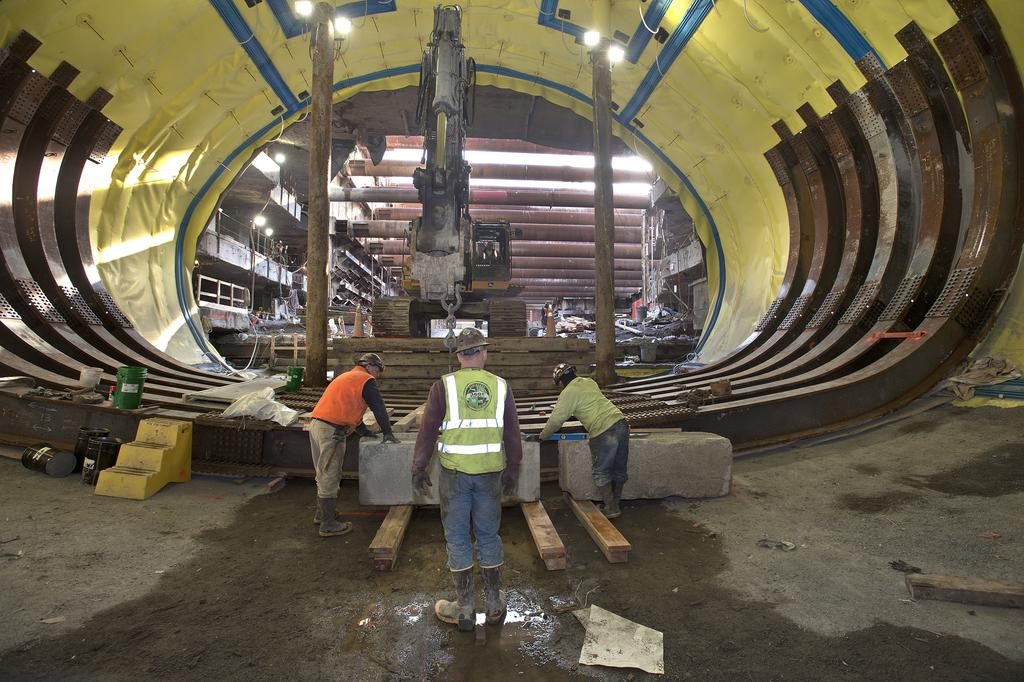How many people are on the floor in the image? There are three people on the floor in the image. What is the main subject of the image? The main subject of the image is a construction of a submarine. What else can be seen in the image besides the people and the submarine? There is a vehicle, pillars, and a building in the image. What type of office supplies can be seen on the people's desks in the image? There are no desks or office supplies present in the image; it features three people on the floor and a construction of a submarine. What color is the scarf worn by the person in the image? There is no scarf visible in the image. 